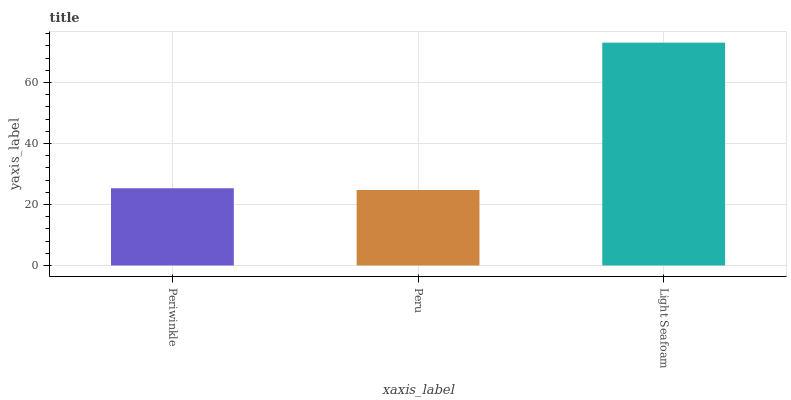Is Peru the minimum?
Answer yes or no. Yes. Is Light Seafoam the maximum?
Answer yes or no. Yes. Is Light Seafoam the minimum?
Answer yes or no. No. Is Peru the maximum?
Answer yes or no. No. Is Light Seafoam greater than Peru?
Answer yes or no. Yes. Is Peru less than Light Seafoam?
Answer yes or no. Yes. Is Peru greater than Light Seafoam?
Answer yes or no. No. Is Light Seafoam less than Peru?
Answer yes or no. No. Is Periwinkle the high median?
Answer yes or no. Yes. Is Periwinkle the low median?
Answer yes or no. Yes. Is Peru the high median?
Answer yes or no. No. Is Light Seafoam the low median?
Answer yes or no. No. 